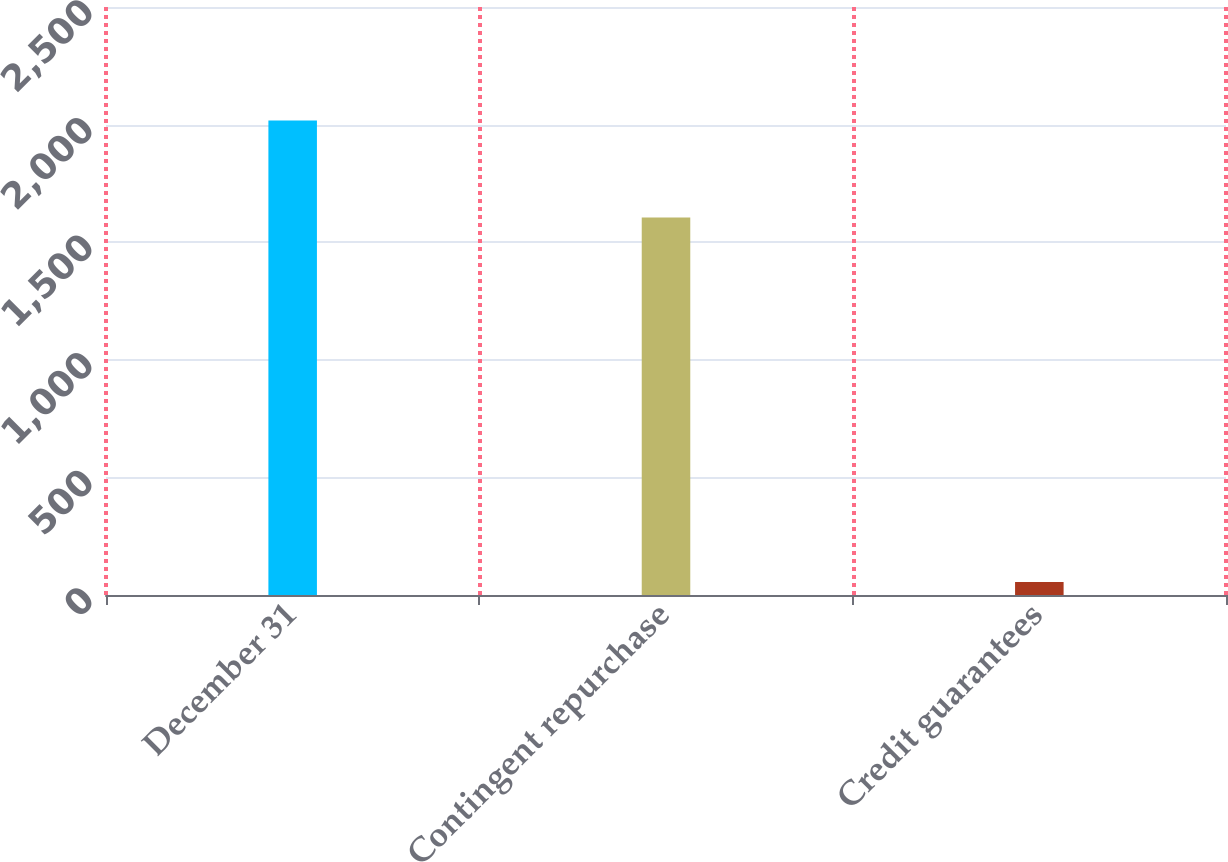Convert chart to OTSL. <chart><loc_0><loc_0><loc_500><loc_500><bar_chart><fcel>December 31<fcel>Contingent repurchase<fcel>Credit guarantees<nl><fcel>2017<fcel>1605<fcel>55<nl></chart> 